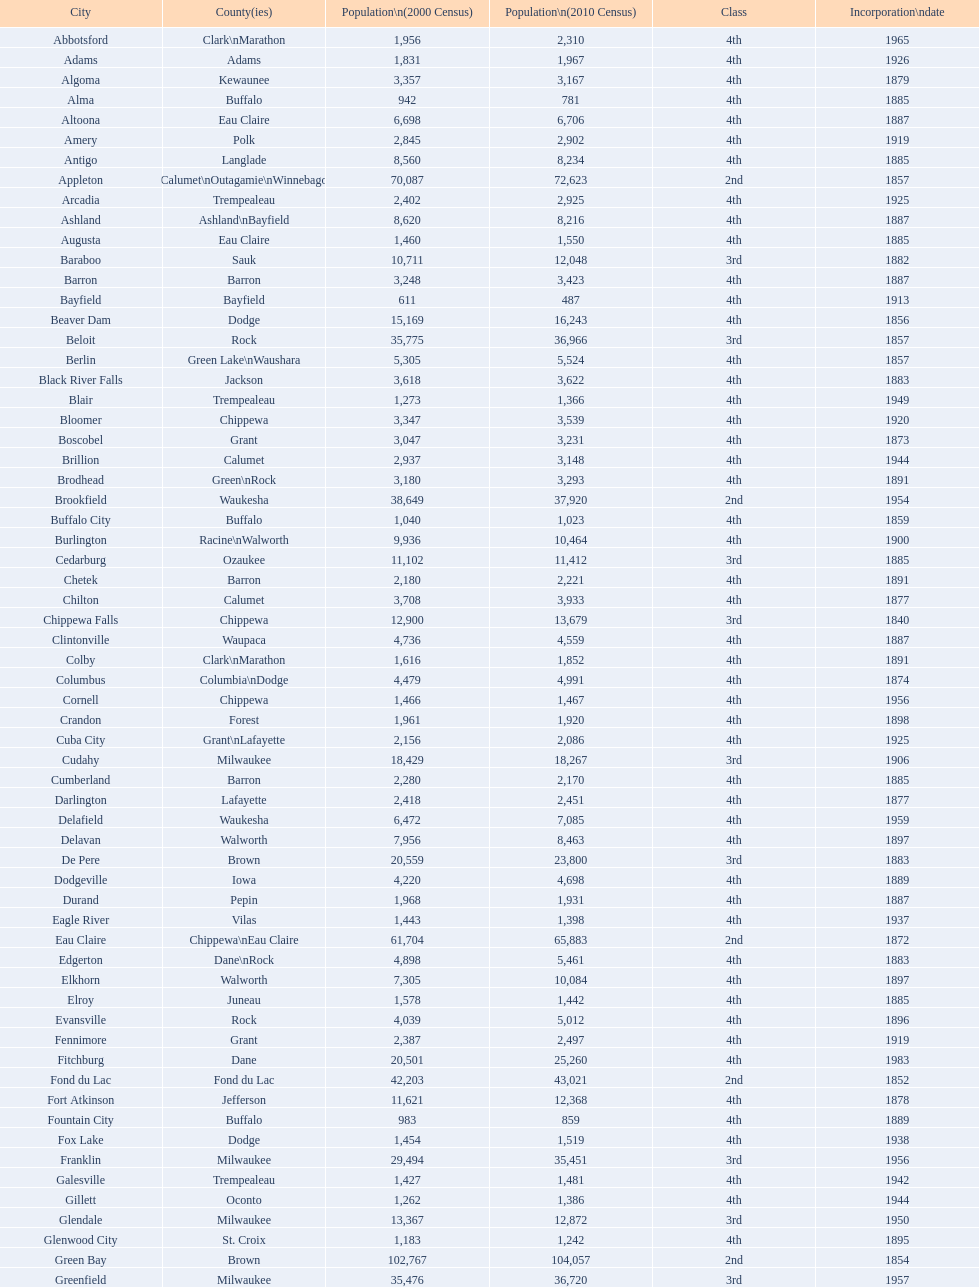In wisconsin, how many cities can be found? 190. 